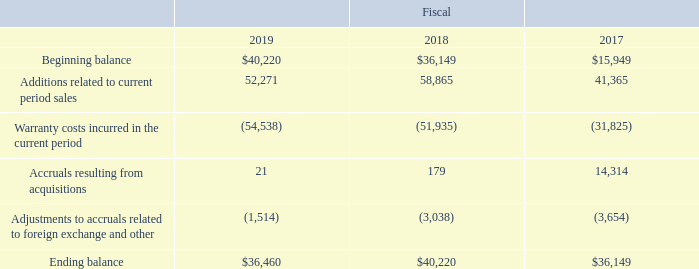Warranty Reserves
We provide warranties on the majority of our product sales and reserves for estimated warranty costs are recorded during the period of sale. The determination of such reserves requires us to make estimates of product return rates and expected costs to repair or replace the products under warranty. We currently establish warranty reserves based on historical warranty costs for each product line. The weighted average warranty period covered is approximately 15 to 18 months. If actual return rates and/or repair and replacement costs differ significantly from our estimates, adjustments to cost of sales may be required in future periods.
Components of the reserve for warranty costs during fiscal 2019, 2018 and 2017 were as follows (in thousands):
What is the approximate weighted average warranty period covered? Approximately 15 to 18 months. What does the determination of such reserves require the company to make? Make estimates of product return rates and expected costs to repair or replace the products under warranty. we currently establish warranty reserves based on historical warranty costs for each product line. In which years was the reserve for warranty costs provided in the table? 2019, 2018, 2017. In which year was the Ending balance the largest? 40,220>36,460>36,149
Answer: 2018. What was the change in Beginning balance in 2019 from 2018?
Answer scale should be: thousand. 40,220-36,149
Answer: 4071. What was the percentage change in Beginning balance in 2019 from 2018?
Answer scale should be: percent. (40,220-36,149)/36,149
Answer: 11.26. 